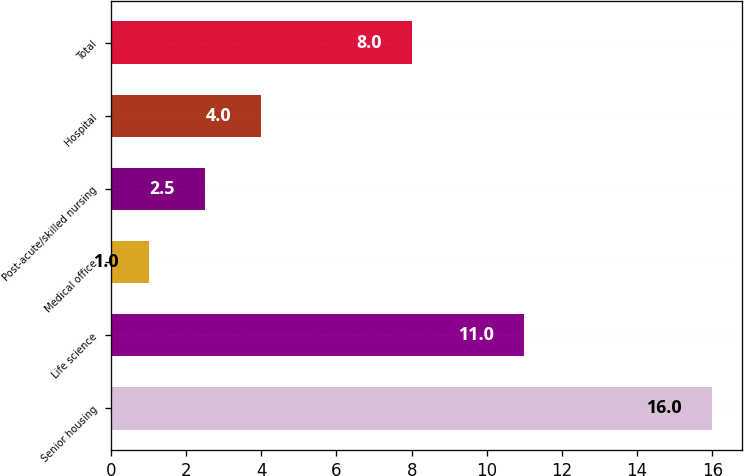<chart> <loc_0><loc_0><loc_500><loc_500><bar_chart><fcel>Senior housing<fcel>Life science<fcel>Medical office<fcel>Post-acute/skilled nursing<fcel>Hospital<fcel>Total<nl><fcel>16<fcel>11<fcel>1<fcel>2.5<fcel>4<fcel>8<nl></chart> 